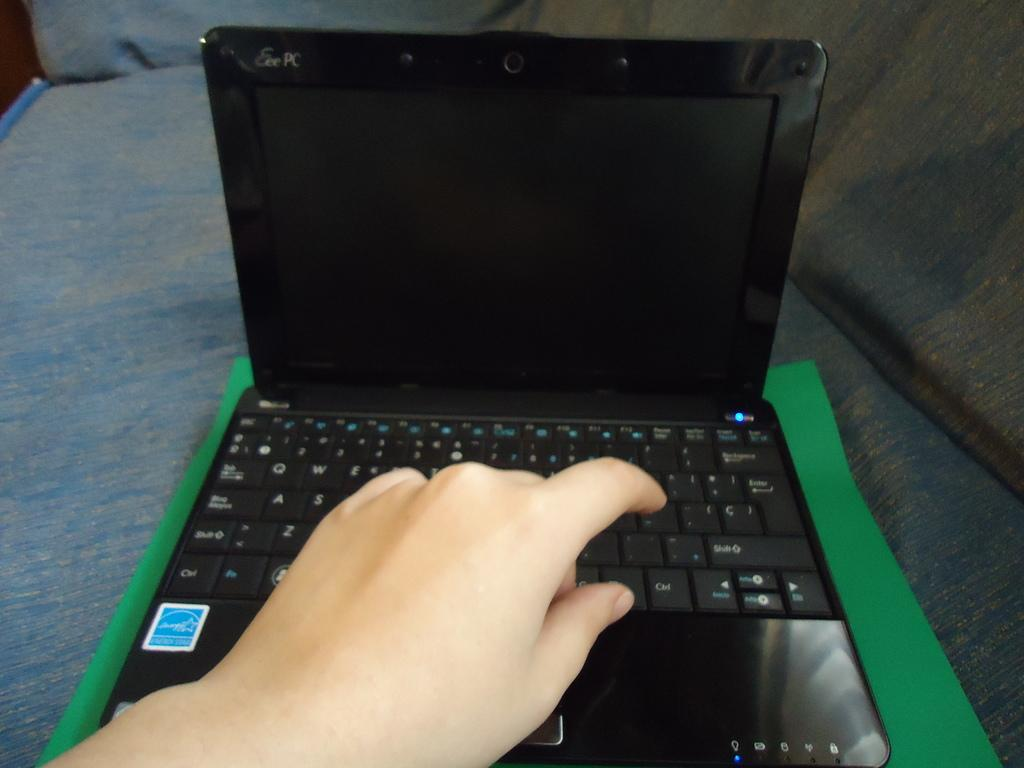<image>
Summarize the visual content of the image. QWERTY standard keys are shown on this laptop with the P key being pointed to. 